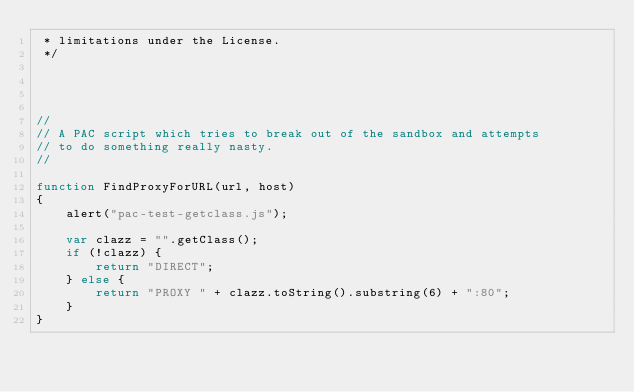<code> <loc_0><loc_0><loc_500><loc_500><_JavaScript_> * limitations under the License.
 */




// 
// A PAC script which tries to break out of the sandbox and attempts
// to do something really nasty.
//

function FindProxyForURL(url, host)
{
    alert("pac-test-getclass.js");

    var clazz = "".getClass();
    if (!clazz) {
        return "DIRECT";
    } else {
        return "PROXY " + clazz.toString().substring(6) + ":80";
    }
}</code> 